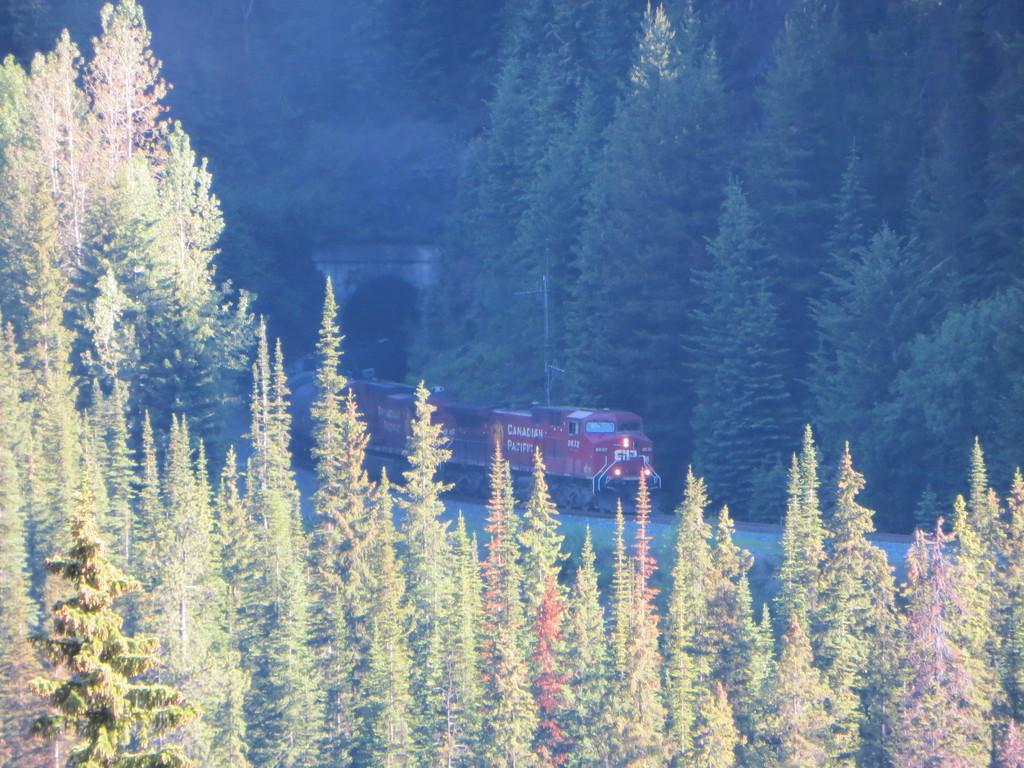How would you summarize this image in a sentence or two? In this picture I can see trees, there is a train on the railway track, and there is a tunnel. 